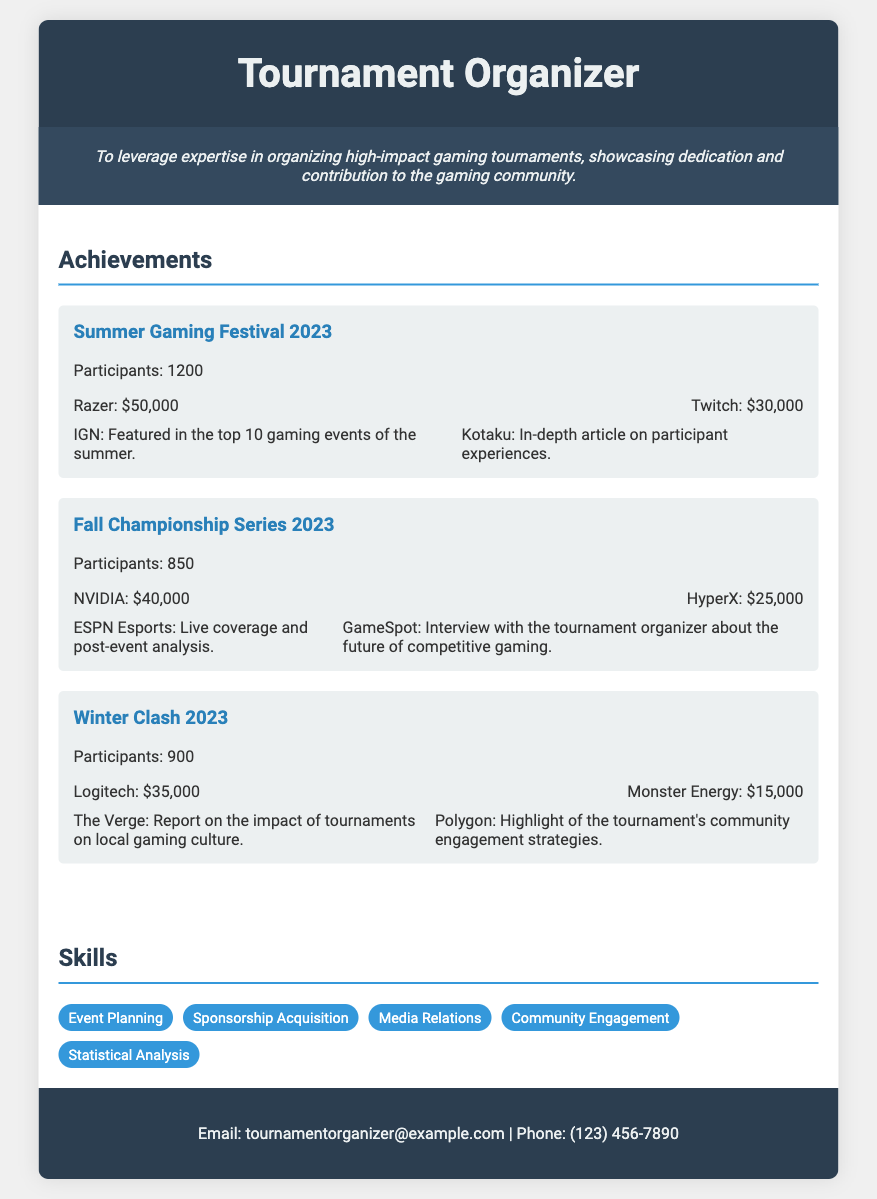What was the participant number for Summer Gaming Festival 2023? The participant number is listed as 1200 for the Summer Gaming Festival 2023.
Answer: 1200 What sponsorship amount was received from Razer? Razer sponsored the event with $50,000, as stated in the achievements section.
Answer: $50,000 Which media outlet featured the tournament in the top 10 gaming events of the summer? IGN is mentioned as featuring the tournament in the top 10 gaming events of the summer.
Answer: IGN How many participants were there in the Fall Championship Series 2023? The document specifies that there were 850 participants in the Fall Championship Series 2023.
Answer: 850 What is the total sponsorship amount for Winter Clash 2023? The total sponsorship for Winter Clash 2023 is found by adding Logitech's $35,000 and Monster Energy's $15,000, which equals $50,000.
Answer: $50,000 Which media outlet covered the live event for Fall Championship Series 2023? ESPN Esports is noted for providing live coverage of the Fall Championship Series 2023.
Answer: ESPN Esports What type of events does the document focus on? The document mentions gaming tournaments as the main focus of the achievements.
Answer: Gaming tournaments What year were all the tournaments organized? All tournaments mentioned were organized in the year 2023.
Answer: 2023 List one skill related to the role of a tournament organizer mentioned in the document. The skills section lists various skills, one being "Event Planning."
Answer: Event Planning 